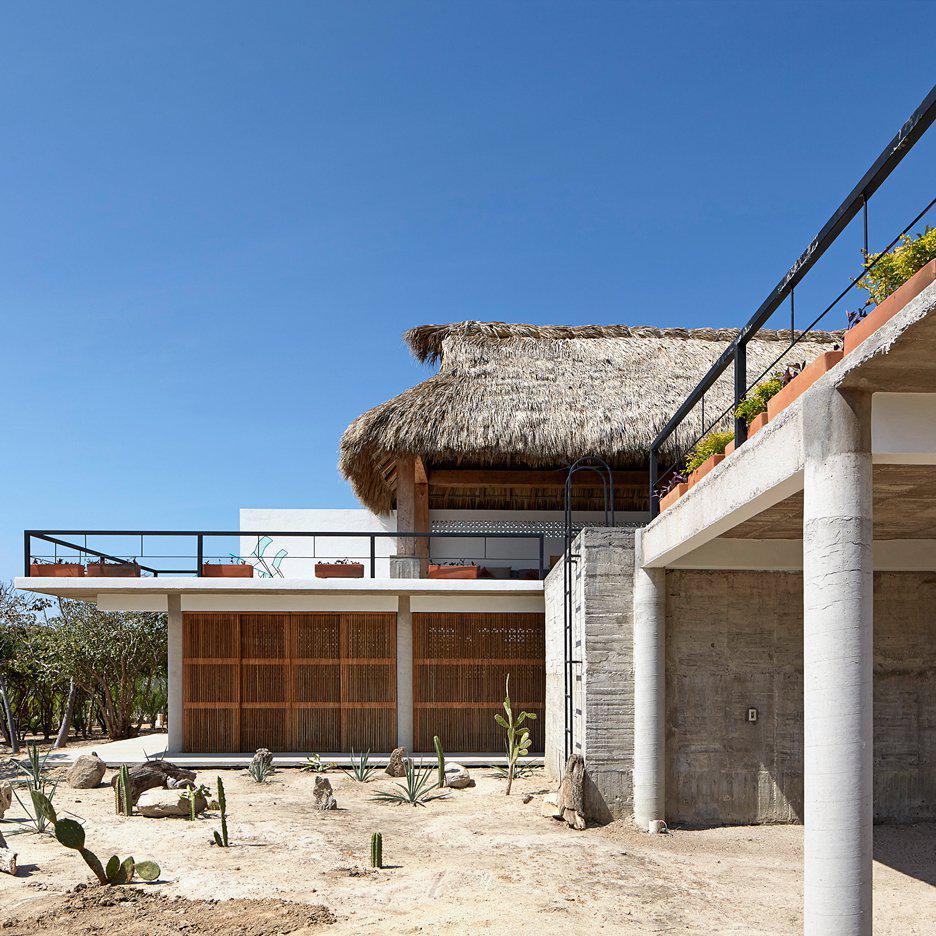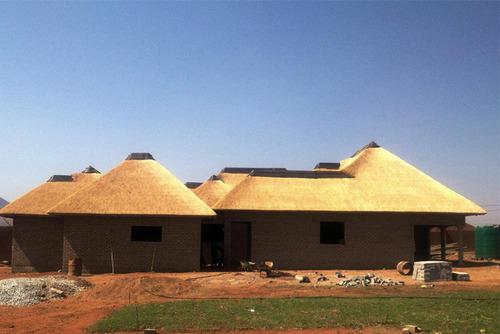The first image is the image on the left, the second image is the image on the right. Evaluate the accuracy of this statement regarding the images: "The building in the image on the left has a chimney.". Is it true? Answer yes or no. No. The first image is the image on the left, the second image is the image on the right. Examine the images to the left and right. Is the description "The right image shows a long grey building with a peaked roof and an open door, but no windows, and the left image shows a building with a peaked roof and windows on the front." accurate? Answer yes or no. No. 